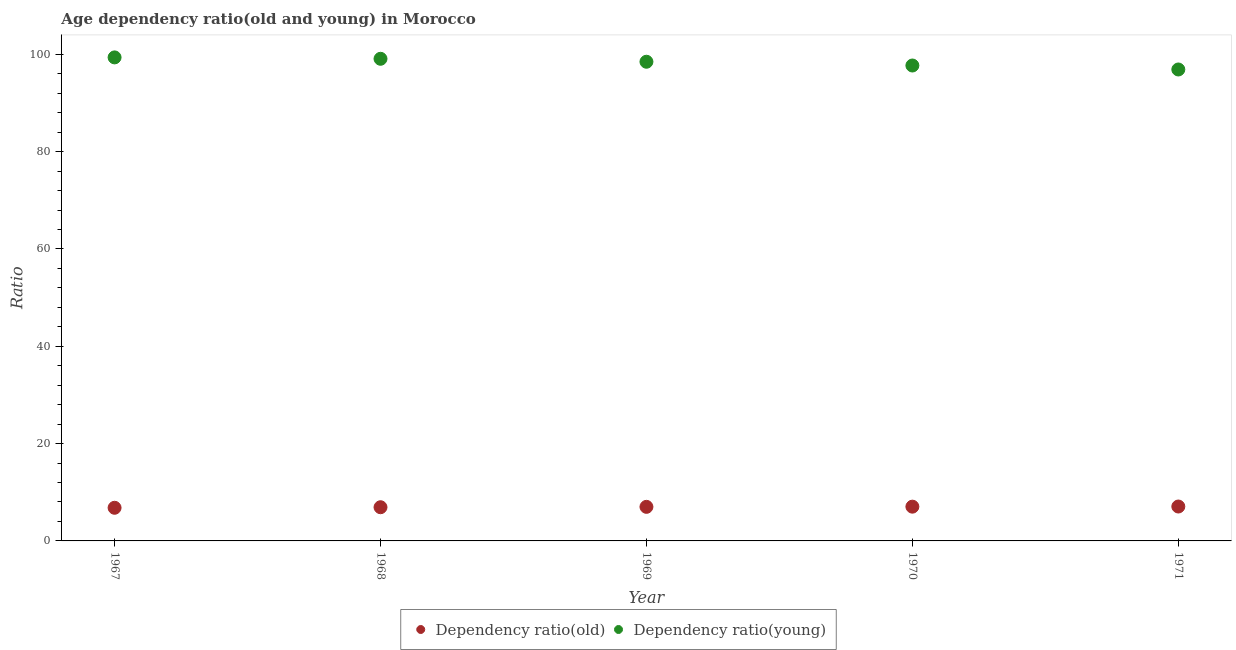What is the age dependency ratio(young) in 1969?
Offer a terse response. 98.48. Across all years, what is the maximum age dependency ratio(young)?
Give a very brief answer. 99.37. Across all years, what is the minimum age dependency ratio(young)?
Your response must be concise. 96.89. In which year was the age dependency ratio(young) maximum?
Make the answer very short. 1967. What is the total age dependency ratio(young) in the graph?
Provide a short and direct response. 491.52. What is the difference between the age dependency ratio(old) in 1968 and that in 1971?
Keep it short and to the point. -0.15. What is the difference between the age dependency ratio(old) in 1970 and the age dependency ratio(young) in 1971?
Your answer should be very brief. -89.85. What is the average age dependency ratio(young) per year?
Give a very brief answer. 98.3. In the year 1970, what is the difference between the age dependency ratio(young) and age dependency ratio(old)?
Your answer should be compact. 90.66. What is the ratio of the age dependency ratio(young) in 1969 to that in 1971?
Make the answer very short. 1.02. Is the difference between the age dependency ratio(old) in 1968 and 1969 greater than the difference between the age dependency ratio(young) in 1968 and 1969?
Make the answer very short. No. What is the difference between the highest and the second highest age dependency ratio(young)?
Make the answer very short. 0.29. What is the difference between the highest and the lowest age dependency ratio(old)?
Give a very brief answer. 0.26. Is the sum of the age dependency ratio(young) in 1967 and 1969 greater than the maximum age dependency ratio(old) across all years?
Ensure brevity in your answer.  Yes. How many dotlines are there?
Your response must be concise. 2. How many years are there in the graph?
Keep it short and to the point. 5. What is the difference between two consecutive major ticks on the Y-axis?
Your response must be concise. 20. Are the values on the major ticks of Y-axis written in scientific E-notation?
Ensure brevity in your answer.  No. Does the graph contain grids?
Provide a succinct answer. No. How are the legend labels stacked?
Provide a succinct answer. Horizontal. What is the title of the graph?
Make the answer very short. Age dependency ratio(old and young) in Morocco. What is the label or title of the Y-axis?
Your response must be concise. Ratio. What is the Ratio in Dependency ratio(old) in 1967?
Offer a very short reply. 6.81. What is the Ratio of Dependency ratio(young) in 1967?
Provide a short and direct response. 99.37. What is the Ratio of Dependency ratio(old) in 1968?
Your response must be concise. 6.92. What is the Ratio in Dependency ratio(young) in 1968?
Your response must be concise. 99.08. What is the Ratio of Dependency ratio(old) in 1969?
Offer a very short reply. 7. What is the Ratio of Dependency ratio(young) in 1969?
Offer a very short reply. 98.48. What is the Ratio of Dependency ratio(old) in 1970?
Offer a very short reply. 7.04. What is the Ratio of Dependency ratio(young) in 1970?
Keep it short and to the point. 97.7. What is the Ratio in Dependency ratio(old) in 1971?
Your response must be concise. 7.07. What is the Ratio in Dependency ratio(young) in 1971?
Provide a short and direct response. 96.89. Across all years, what is the maximum Ratio in Dependency ratio(old)?
Ensure brevity in your answer.  7.07. Across all years, what is the maximum Ratio in Dependency ratio(young)?
Make the answer very short. 99.37. Across all years, what is the minimum Ratio in Dependency ratio(old)?
Give a very brief answer. 6.81. Across all years, what is the minimum Ratio of Dependency ratio(young)?
Give a very brief answer. 96.89. What is the total Ratio of Dependency ratio(old) in the graph?
Offer a terse response. 34.85. What is the total Ratio in Dependency ratio(young) in the graph?
Your answer should be very brief. 491.52. What is the difference between the Ratio of Dependency ratio(old) in 1967 and that in 1968?
Offer a terse response. -0.11. What is the difference between the Ratio of Dependency ratio(young) in 1967 and that in 1968?
Your response must be concise. 0.29. What is the difference between the Ratio of Dependency ratio(old) in 1967 and that in 1969?
Offer a terse response. -0.19. What is the difference between the Ratio of Dependency ratio(young) in 1967 and that in 1969?
Provide a succinct answer. 0.9. What is the difference between the Ratio in Dependency ratio(old) in 1967 and that in 1970?
Give a very brief answer. -0.23. What is the difference between the Ratio of Dependency ratio(young) in 1967 and that in 1970?
Keep it short and to the point. 1.67. What is the difference between the Ratio of Dependency ratio(old) in 1967 and that in 1971?
Ensure brevity in your answer.  -0.26. What is the difference between the Ratio in Dependency ratio(young) in 1967 and that in 1971?
Keep it short and to the point. 2.48. What is the difference between the Ratio in Dependency ratio(old) in 1968 and that in 1969?
Offer a terse response. -0.08. What is the difference between the Ratio in Dependency ratio(young) in 1968 and that in 1969?
Provide a short and direct response. 0.61. What is the difference between the Ratio of Dependency ratio(old) in 1968 and that in 1970?
Offer a terse response. -0.12. What is the difference between the Ratio of Dependency ratio(young) in 1968 and that in 1970?
Offer a terse response. 1.38. What is the difference between the Ratio in Dependency ratio(old) in 1968 and that in 1971?
Your answer should be compact. -0.15. What is the difference between the Ratio in Dependency ratio(young) in 1968 and that in 1971?
Offer a very short reply. 2.2. What is the difference between the Ratio in Dependency ratio(old) in 1969 and that in 1970?
Your response must be concise. -0.04. What is the difference between the Ratio of Dependency ratio(young) in 1969 and that in 1970?
Offer a terse response. 0.77. What is the difference between the Ratio in Dependency ratio(old) in 1969 and that in 1971?
Your answer should be compact. -0.07. What is the difference between the Ratio in Dependency ratio(young) in 1969 and that in 1971?
Keep it short and to the point. 1.59. What is the difference between the Ratio in Dependency ratio(old) in 1970 and that in 1971?
Offer a very short reply. -0.03. What is the difference between the Ratio of Dependency ratio(young) in 1970 and that in 1971?
Provide a succinct answer. 0.82. What is the difference between the Ratio of Dependency ratio(old) in 1967 and the Ratio of Dependency ratio(young) in 1968?
Provide a succinct answer. -92.27. What is the difference between the Ratio of Dependency ratio(old) in 1967 and the Ratio of Dependency ratio(young) in 1969?
Ensure brevity in your answer.  -91.66. What is the difference between the Ratio in Dependency ratio(old) in 1967 and the Ratio in Dependency ratio(young) in 1970?
Give a very brief answer. -90.89. What is the difference between the Ratio in Dependency ratio(old) in 1967 and the Ratio in Dependency ratio(young) in 1971?
Your response must be concise. -90.08. What is the difference between the Ratio of Dependency ratio(old) in 1968 and the Ratio of Dependency ratio(young) in 1969?
Ensure brevity in your answer.  -91.55. What is the difference between the Ratio of Dependency ratio(old) in 1968 and the Ratio of Dependency ratio(young) in 1970?
Keep it short and to the point. -90.78. What is the difference between the Ratio of Dependency ratio(old) in 1968 and the Ratio of Dependency ratio(young) in 1971?
Give a very brief answer. -89.96. What is the difference between the Ratio in Dependency ratio(old) in 1969 and the Ratio in Dependency ratio(young) in 1970?
Ensure brevity in your answer.  -90.7. What is the difference between the Ratio in Dependency ratio(old) in 1969 and the Ratio in Dependency ratio(young) in 1971?
Your response must be concise. -89.88. What is the difference between the Ratio in Dependency ratio(old) in 1970 and the Ratio in Dependency ratio(young) in 1971?
Provide a short and direct response. -89.85. What is the average Ratio of Dependency ratio(old) per year?
Offer a very short reply. 6.97. What is the average Ratio of Dependency ratio(young) per year?
Provide a short and direct response. 98.3. In the year 1967, what is the difference between the Ratio in Dependency ratio(old) and Ratio in Dependency ratio(young)?
Provide a short and direct response. -92.56. In the year 1968, what is the difference between the Ratio of Dependency ratio(old) and Ratio of Dependency ratio(young)?
Offer a terse response. -92.16. In the year 1969, what is the difference between the Ratio of Dependency ratio(old) and Ratio of Dependency ratio(young)?
Keep it short and to the point. -91.47. In the year 1970, what is the difference between the Ratio in Dependency ratio(old) and Ratio in Dependency ratio(young)?
Ensure brevity in your answer.  -90.66. In the year 1971, what is the difference between the Ratio in Dependency ratio(old) and Ratio in Dependency ratio(young)?
Provide a succinct answer. -89.82. What is the ratio of the Ratio of Dependency ratio(old) in 1967 to that in 1968?
Keep it short and to the point. 0.98. What is the ratio of the Ratio in Dependency ratio(young) in 1967 to that in 1968?
Your answer should be very brief. 1. What is the ratio of the Ratio of Dependency ratio(old) in 1967 to that in 1969?
Provide a short and direct response. 0.97. What is the ratio of the Ratio of Dependency ratio(young) in 1967 to that in 1969?
Your answer should be very brief. 1.01. What is the ratio of the Ratio of Dependency ratio(old) in 1967 to that in 1970?
Your response must be concise. 0.97. What is the ratio of the Ratio of Dependency ratio(young) in 1967 to that in 1970?
Keep it short and to the point. 1.02. What is the ratio of the Ratio of Dependency ratio(old) in 1967 to that in 1971?
Your answer should be very brief. 0.96. What is the ratio of the Ratio of Dependency ratio(young) in 1967 to that in 1971?
Give a very brief answer. 1.03. What is the ratio of the Ratio in Dependency ratio(old) in 1968 to that in 1969?
Ensure brevity in your answer.  0.99. What is the ratio of the Ratio in Dependency ratio(young) in 1968 to that in 1969?
Your answer should be compact. 1.01. What is the ratio of the Ratio in Dependency ratio(old) in 1968 to that in 1970?
Give a very brief answer. 0.98. What is the ratio of the Ratio of Dependency ratio(young) in 1968 to that in 1970?
Your answer should be compact. 1.01. What is the ratio of the Ratio in Dependency ratio(old) in 1968 to that in 1971?
Offer a terse response. 0.98. What is the ratio of the Ratio in Dependency ratio(young) in 1968 to that in 1971?
Make the answer very short. 1.02. What is the ratio of the Ratio of Dependency ratio(young) in 1969 to that in 1970?
Offer a terse response. 1.01. What is the ratio of the Ratio in Dependency ratio(old) in 1969 to that in 1971?
Your answer should be very brief. 0.99. What is the ratio of the Ratio in Dependency ratio(young) in 1969 to that in 1971?
Keep it short and to the point. 1.02. What is the ratio of the Ratio in Dependency ratio(old) in 1970 to that in 1971?
Offer a very short reply. 1. What is the ratio of the Ratio in Dependency ratio(young) in 1970 to that in 1971?
Offer a terse response. 1.01. What is the difference between the highest and the second highest Ratio of Dependency ratio(old)?
Your answer should be very brief. 0.03. What is the difference between the highest and the second highest Ratio in Dependency ratio(young)?
Offer a terse response. 0.29. What is the difference between the highest and the lowest Ratio of Dependency ratio(old)?
Your answer should be compact. 0.26. What is the difference between the highest and the lowest Ratio in Dependency ratio(young)?
Provide a succinct answer. 2.48. 